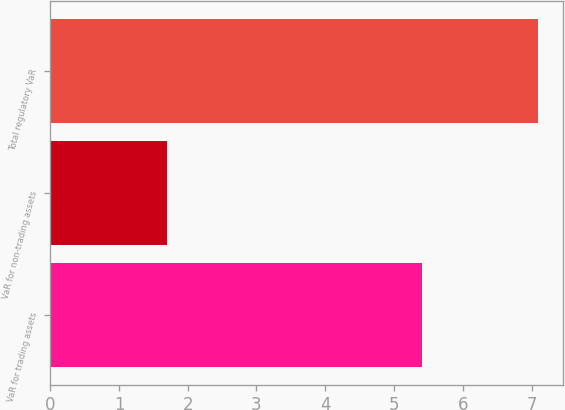Convert chart. <chart><loc_0><loc_0><loc_500><loc_500><bar_chart><fcel>VaR for trading assets<fcel>VaR for non-trading assets<fcel>Total regulatory VaR<nl><fcel>5.4<fcel>1.7<fcel>7.1<nl></chart> 